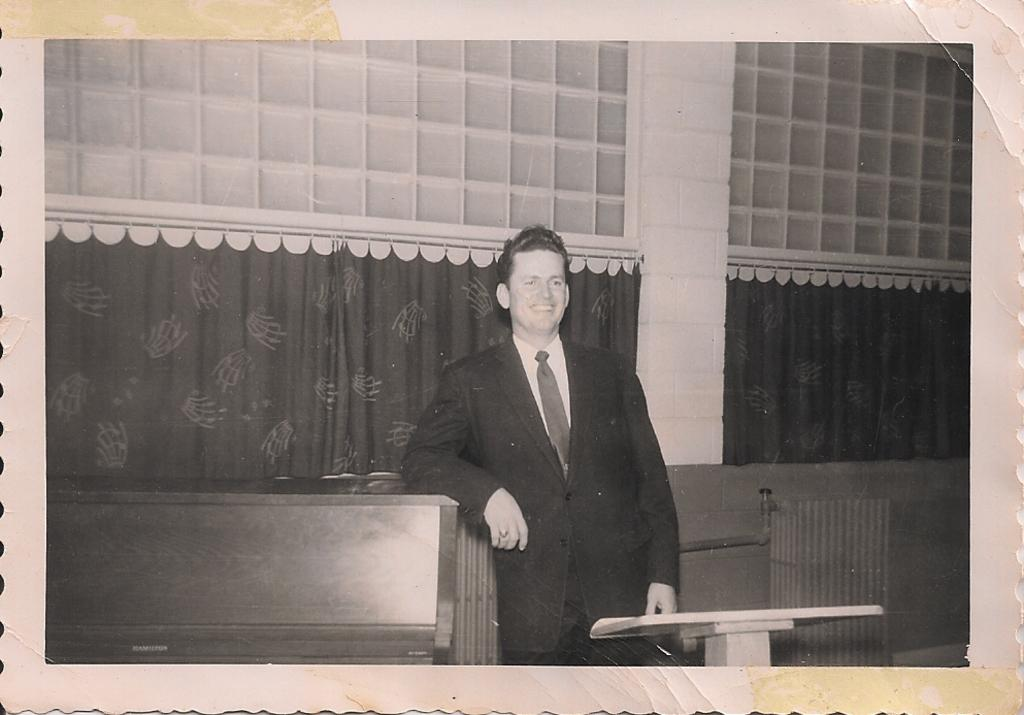What is the main subject of the image? There is a person standing in the image. What can be seen in the background of the image? The background of the image includes curtains. What is the color scheme of the image? The image is in black and white. How many friends are visible in the image? There are no friends visible in the image; it only features a person standing. What type of air is present in the image? There is no specific type of air mentioned or depicted in the image. 